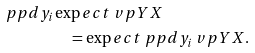Convert formula to latex. <formula><loc_0><loc_0><loc_500><loc_500>\ p p d { y _ { i } } & \exp e c t { \ v p Y X } \\ & \quad = \exp e c t { \ p p d { y _ { i } } \ v p Y X } .</formula> 